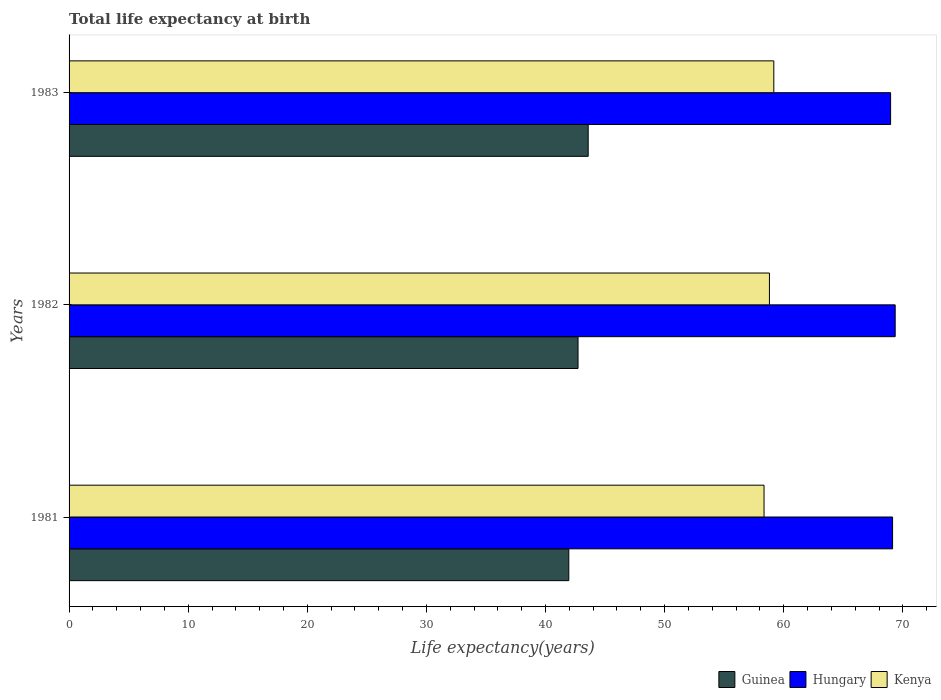How many different coloured bars are there?
Your answer should be compact. 3. Are the number of bars per tick equal to the number of legend labels?
Offer a terse response. Yes. How many bars are there on the 2nd tick from the top?
Ensure brevity in your answer.  3. What is the label of the 3rd group of bars from the top?
Ensure brevity in your answer.  1981. In how many cases, is the number of bars for a given year not equal to the number of legend labels?
Make the answer very short. 0. What is the life expectancy at birth in in Guinea in 1981?
Ensure brevity in your answer.  41.96. Across all years, what is the maximum life expectancy at birth in in Guinea?
Keep it short and to the point. 43.58. Across all years, what is the minimum life expectancy at birth in in Guinea?
Offer a very short reply. 41.96. In which year was the life expectancy at birth in in Guinea maximum?
Keep it short and to the point. 1983. In which year was the life expectancy at birth in in Guinea minimum?
Provide a succinct answer. 1981. What is the total life expectancy at birth in in Hungary in the graph?
Offer a very short reply. 207.47. What is the difference between the life expectancy at birth in in Kenya in 1982 and that in 1983?
Your answer should be very brief. -0.37. What is the difference between the life expectancy at birth in in Hungary in 1981 and the life expectancy at birth in in Guinea in 1983?
Ensure brevity in your answer.  25.56. What is the average life expectancy at birth in in Kenya per year?
Ensure brevity in your answer.  58.77. In the year 1982, what is the difference between the life expectancy at birth in in Guinea and life expectancy at birth in in Hungary?
Ensure brevity in your answer.  -26.63. In how many years, is the life expectancy at birth in in Kenya greater than 46 years?
Your answer should be very brief. 3. What is the ratio of the life expectancy at birth in in Guinea in 1981 to that in 1982?
Provide a succinct answer. 0.98. What is the difference between the highest and the second highest life expectancy at birth in in Hungary?
Provide a short and direct response. 0.22. What is the difference between the highest and the lowest life expectancy at birth in in Hungary?
Provide a short and direct response. 0.38. In how many years, is the life expectancy at birth in in Guinea greater than the average life expectancy at birth in in Guinea taken over all years?
Make the answer very short. 1. What does the 1st bar from the top in 1981 represents?
Ensure brevity in your answer.  Kenya. What does the 2nd bar from the bottom in 1981 represents?
Make the answer very short. Hungary. How many bars are there?
Your answer should be very brief. 9. Are all the bars in the graph horizontal?
Offer a very short reply. Yes. How many years are there in the graph?
Your answer should be very brief. 3. Where does the legend appear in the graph?
Your answer should be very brief. Bottom right. How are the legend labels stacked?
Provide a succinct answer. Horizontal. What is the title of the graph?
Provide a short and direct response. Total life expectancy at birth. What is the label or title of the X-axis?
Your response must be concise. Life expectancy(years). What is the Life expectancy(years) of Guinea in 1981?
Your answer should be compact. 41.96. What is the Life expectancy(years) of Hungary in 1981?
Offer a very short reply. 69.14. What is the Life expectancy(years) in Kenya in 1981?
Give a very brief answer. 58.35. What is the Life expectancy(years) of Guinea in 1982?
Provide a succinct answer. 42.73. What is the Life expectancy(years) of Hungary in 1982?
Your response must be concise. 69.36. What is the Life expectancy(years) in Kenya in 1982?
Provide a succinct answer. 58.8. What is the Life expectancy(years) in Guinea in 1983?
Provide a short and direct response. 43.58. What is the Life expectancy(years) in Hungary in 1983?
Give a very brief answer. 68.97. What is the Life expectancy(years) of Kenya in 1983?
Provide a succinct answer. 59.17. Across all years, what is the maximum Life expectancy(years) in Guinea?
Your answer should be very brief. 43.58. Across all years, what is the maximum Life expectancy(years) in Hungary?
Your answer should be very brief. 69.36. Across all years, what is the maximum Life expectancy(years) of Kenya?
Provide a short and direct response. 59.17. Across all years, what is the minimum Life expectancy(years) of Guinea?
Your response must be concise. 41.96. Across all years, what is the minimum Life expectancy(years) in Hungary?
Ensure brevity in your answer.  68.97. Across all years, what is the minimum Life expectancy(years) of Kenya?
Your response must be concise. 58.35. What is the total Life expectancy(years) in Guinea in the graph?
Provide a short and direct response. 128.27. What is the total Life expectancy(years) in Hungary in the graph?
Your response must be concise. 207.47. What is the total Life expectancy(years) of Kenya in the graph?
Your response must be concise. 176.32. What is the difference between the Life expectancy(years) of Guinea in 1981 and that in 1982?
Your answer should be very brief. -0.78. What is the difference between the Life expectancy(years) of Hungary in 1981 and that in 1982?
Offer a terse response. -0.22. What is the difference between the Life expectancy(years) of Kenya in 1981 and that in 1982?
Offer a very short reply. -0.45. What is the difference between the Life expectancy(years) of Guinea in 1981 and that in 1983?
Provide a succinct answer. -1.63. What is the difference between the Life expectancy(years) of Hungary in 1981 and that in 1983?
Make the answer very short. 0.17. What is the difference between the Life expectancy(years) in Kenya in 1981 and that in 1983?
Give a very brief answer. -0.82. What is the difference between the Life expectancy(years) in Guinea in 1982 and that in 1983?
Your answer should be very brief. -0.85. What is the difference between the Life expectancy(years) in Hungary in 1982 and that in 1983?
Make the answer very short. 0.38. What is the difference between the Life expectancy(years) in Kenya in 1982 and that in 1983?
Provide a short and direct response. -0.37. What is the difference between the Life expectancy(years) of Guinea in 1981 and the Life expectancy(years) of Hungary in 1982?
Your answer should be very brief. -27.4. What is the difference between the Life expectancy(years) in Guinea in 1981 and the Life expectancy(years) in Kenya in 1982?
Your response must be concise. -16.84. What is the difference between the Life expectancy(years) of Hungary in 1981 and the Life expectancy(years) of Kenya in 1982?
Your answer should be compact. 10.34. What is the difference between the Life expectancy(years) of Guinea in 1981 and the Life expectancy(years) of Hungary in 1983?
Keep it short and to the point. -27.02. What is the difference between the Life expectancy(years) of Guinea in 1981 and the Life expectancy(years) of Kenya in 1983?
Keep it short and to the point. -17.21. What is the difference between the Life expectancy(years) of Hungary in 1981 and the Life expectancy(years) of Kenya in 1983?
Give a very brief answer. 9.97. What is the difference between the Life expectancy(years) of Guinea in 1982 and the Life expectancy(years) of Hungary in 1983?
Provide a short and direct response. -26.24. What is the difference between the Life expectancy(years) in Guinea in 1982 and the Life expectancy(years) in Kenya in 1983?
Keep it short and to the point. -16.44. What is the difference between the Life expectancy(years) in Hungary in 1982 and the Life expectancy(years) in Kenya in 1983?
Offer a very short reply. 10.19. What is the average Life expectancy(years) in Guinea per year?
Your answer should be very brief. 42.76. What is the average Life expectancy(years) of Hungary per year?
Provide a succinct answer. 69.16. What is the average Life expectancy(years) in Kenya per year?
Make the answer very short. 58.77. In the year 1981, what is the difference between the Life expectancy(years) of Guinea and Life expectancy(years) of Hungary?
Provide a succinct answer. -27.18. In the year 1981, what is the difference between the Life expectancy(years) in Guinea and Life expectancy(years) in Kenya?
Your answer should be very brief. -16.39. In the year 1981, what is the difference between the Life expectancy(years) of Hungary and Life expectancy(years) of Kenya?
Your response must be concise. 10.79. In the year 1982, what is the difference between the Life expectancy(years) of Guinea and Life expectancy(years) of Hungary?
Give a very brief answer. -26.63. In the year 1982, what is the difference between the Life expectancy(years) in Guinea and Life expectancy(years) in Kenya?
Ensure brevity in your answer.  -16.07. In the year 1982, what is the difference between the Life expectancy(years) in Hungary and Life expectancy(years) in Kenya?
Your response must be concise. 10.56. In the year 1983, what is the difference between the Life expectancy(years) of Guinea and Life expectancy(years) of Hungary?
Give a very brief answer. -25.39. In the year 1983, what is the difference between the Life expectancy(years) of Guinea and Life expectancy(years) of Kenya?
Make the answer very short. -15.59. In the year 1983, what is the difference between the Life expectancy(years) of Hungary and Life expectancy(years) of Kenya?
Provide a short and direct response. 9.81. What is the ratio of the Life expectancy(years) of Guinea in 1981 to that in 1982?
Offer a very short reply. 0.98. What is the ratio of the Life expectancy(years) of Hungary in 1981 to that in 1982?
Keep it short and to the point. 1. What is the ratio of the Life expectancy(years) in Guinea in 1981 to that in 1983?
Your response must be concise. 0.96. What is the ratio of the Life expectancy(years) in Kenya in 1981 to that in 1983?
Provide a short and direct response. 0.99. What is the ratio of the Life expectancy(years) in Guinea in 1982 to that in 1983?
Make the answer very short. 0.98. What is the ratio of the Life expectancy(years) of Hungary in 1982 to that in 1983?
Keep it short and to the point. 1.01. What is the difference between the highest and the second highest Life expectancy(years) of Guinea?
Keep it short and to the point. 0.85. What is the difference between the highest and the second highest Life expectancy(years) of Hungary?
Make the answer very short. 0.22. What is the difference between the highest and the second highest Life expectancy(years) in Kenya?
Your answer should be compact. 0.37. What is the difference between the highest and the lowest Life expectancy(years) in Guinea?
Provide a short and direct response. 1.63. What is the difference between the highest and the lowest Life expectancy(years) of Hungary?
Your response must be concise. 0.38. What is the difference between the highest and the lowest Life expectancy(years) of Kenya?
Give a very brief answer. 0.82. 